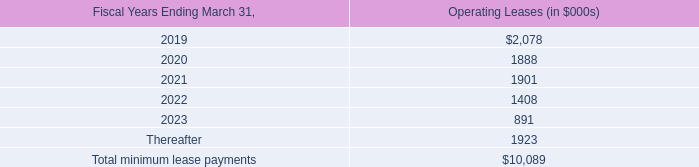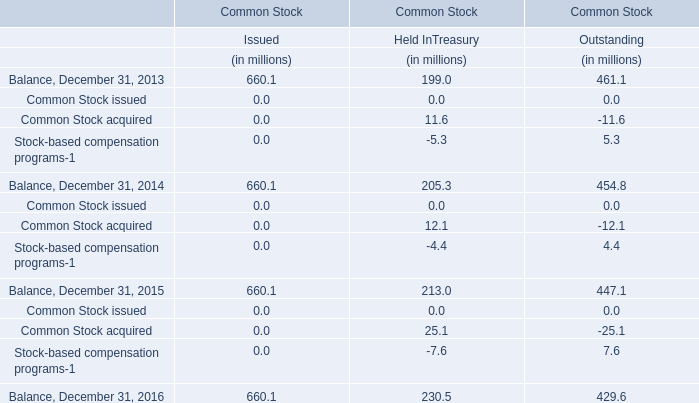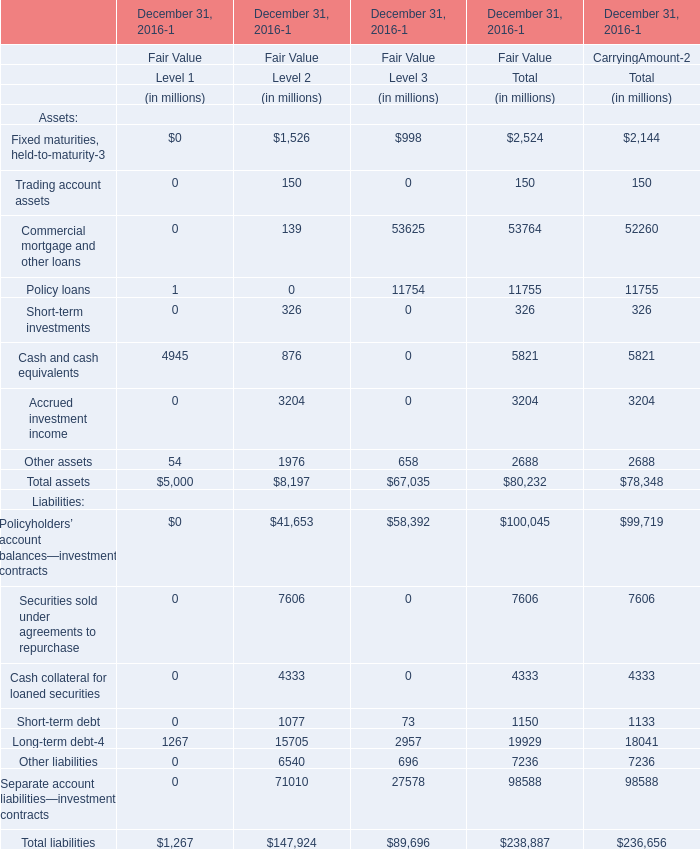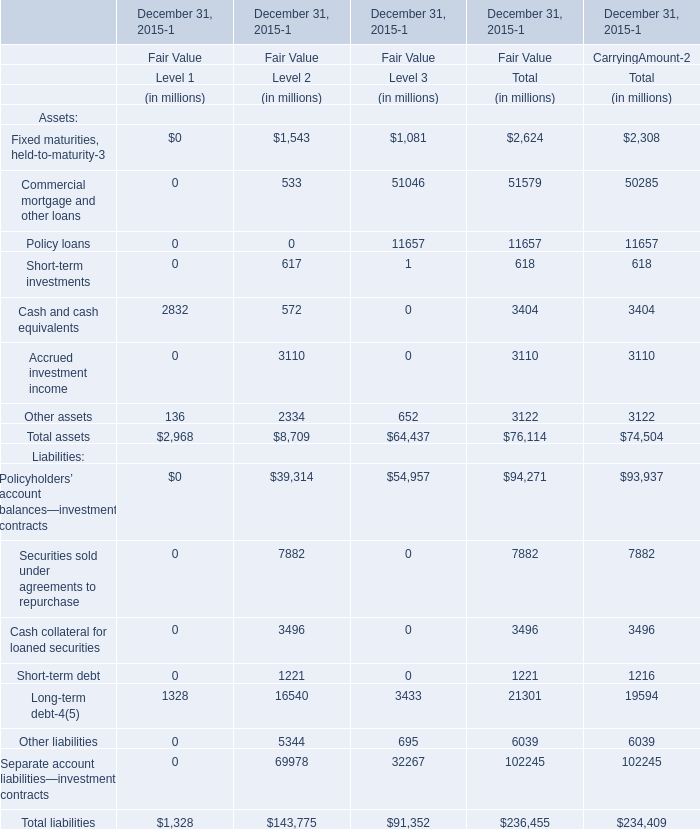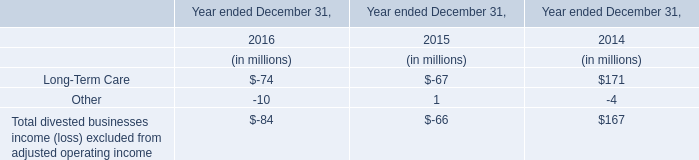What is the ratio of all asset for fair value of that are in the range of 3000 and 10000 to the sum of asset, in 2015? 
Computations: (((3404 + 3110) + 3122) / ((((((2624 + 51579) + 11657) + 618) + 3404) + 3110) + 3122))
Answer: 0.1266. 